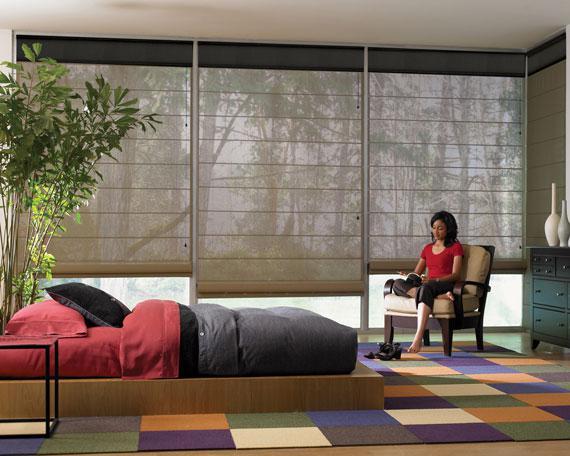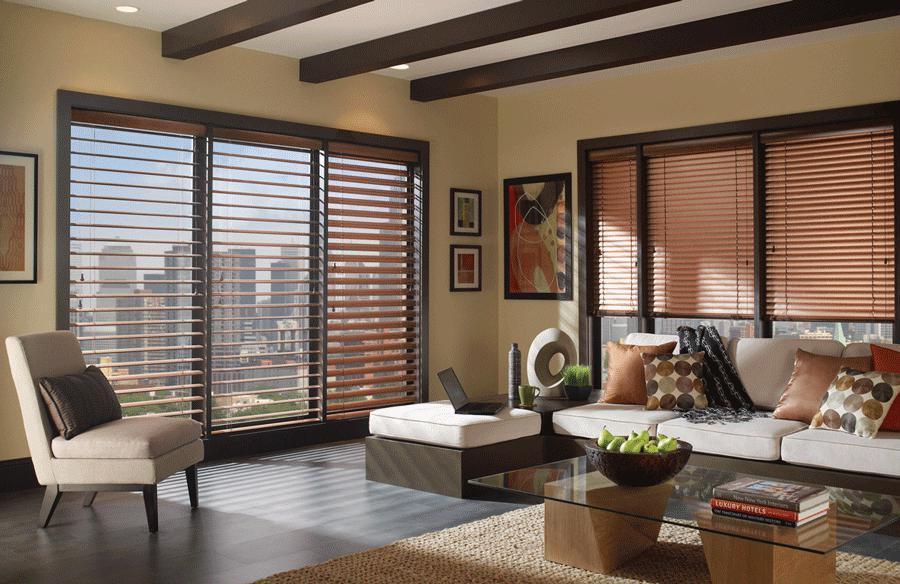The first image is the image on the left, the second image is the image on the right. For the images displayed, is the sentence "There are no less than five blinds." factually correct? Answer yes or no. Yes. The first image is the image on the left, the second image is the image on the right. Analyze the images presented: Is the assertion "There is a bed in front of a nature backdrop." valid? Answer yes or no. Yes. 